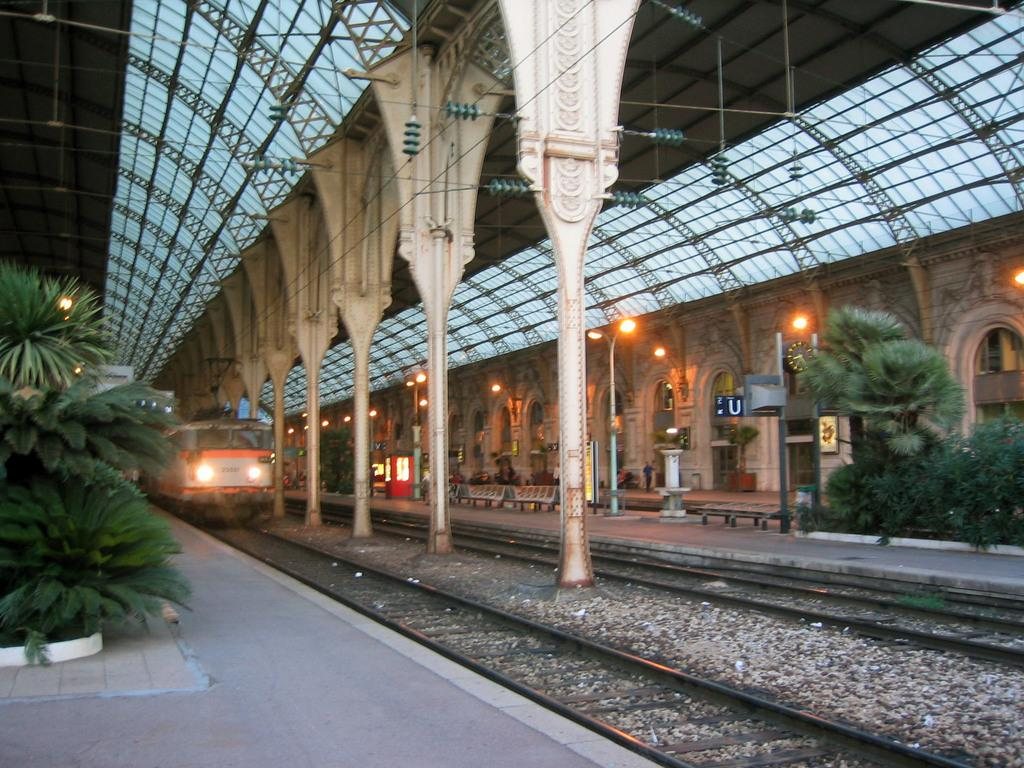What is the main subject of the image? The main subject of the image is a train. What can be seen in the image besides the train? There is a railway track, an arch, plants, lights, a roof, and other objects in the image. Can you describe the railway track in the image? The railway track is visible in the image, and it is likely the path the train is traveling on. What type of lighting is present in the image? There are lights in the image, but their specific type is not mentioned in the facts. What other objects can be seen in the image? The facts mention that there are other objects in the image, but they do not specify what they are. How much profit does the train generate in the image? The image does not provide any information about the train's profit, so it cannot be determined. 